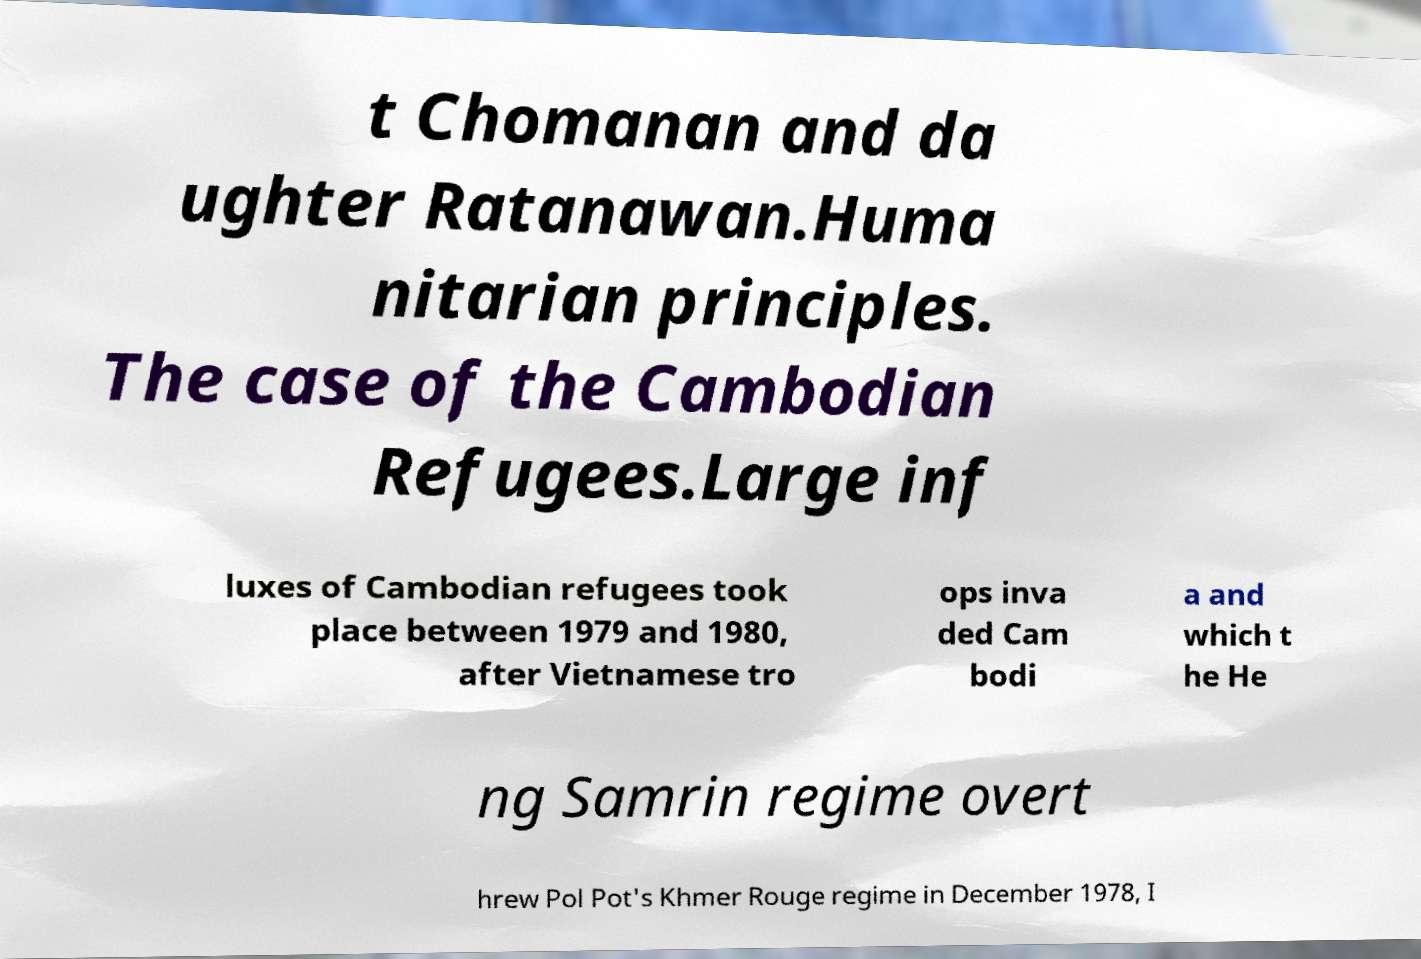For documentation purposes, I need the text within this image transcribed. Could you provide that? t Chomanan and da ughter Ratanawan.Huma nitarian principles. The case of the Cambodian Refugees.Large inf luxes of Cambodian refugees took place between 1979 and 1980, after Vietnamese tro ops inva ded Cam bodi a and which t he He ng Samrin regime overt hrew Pol Pot's Khmer Rouge regime in December 1978, I 